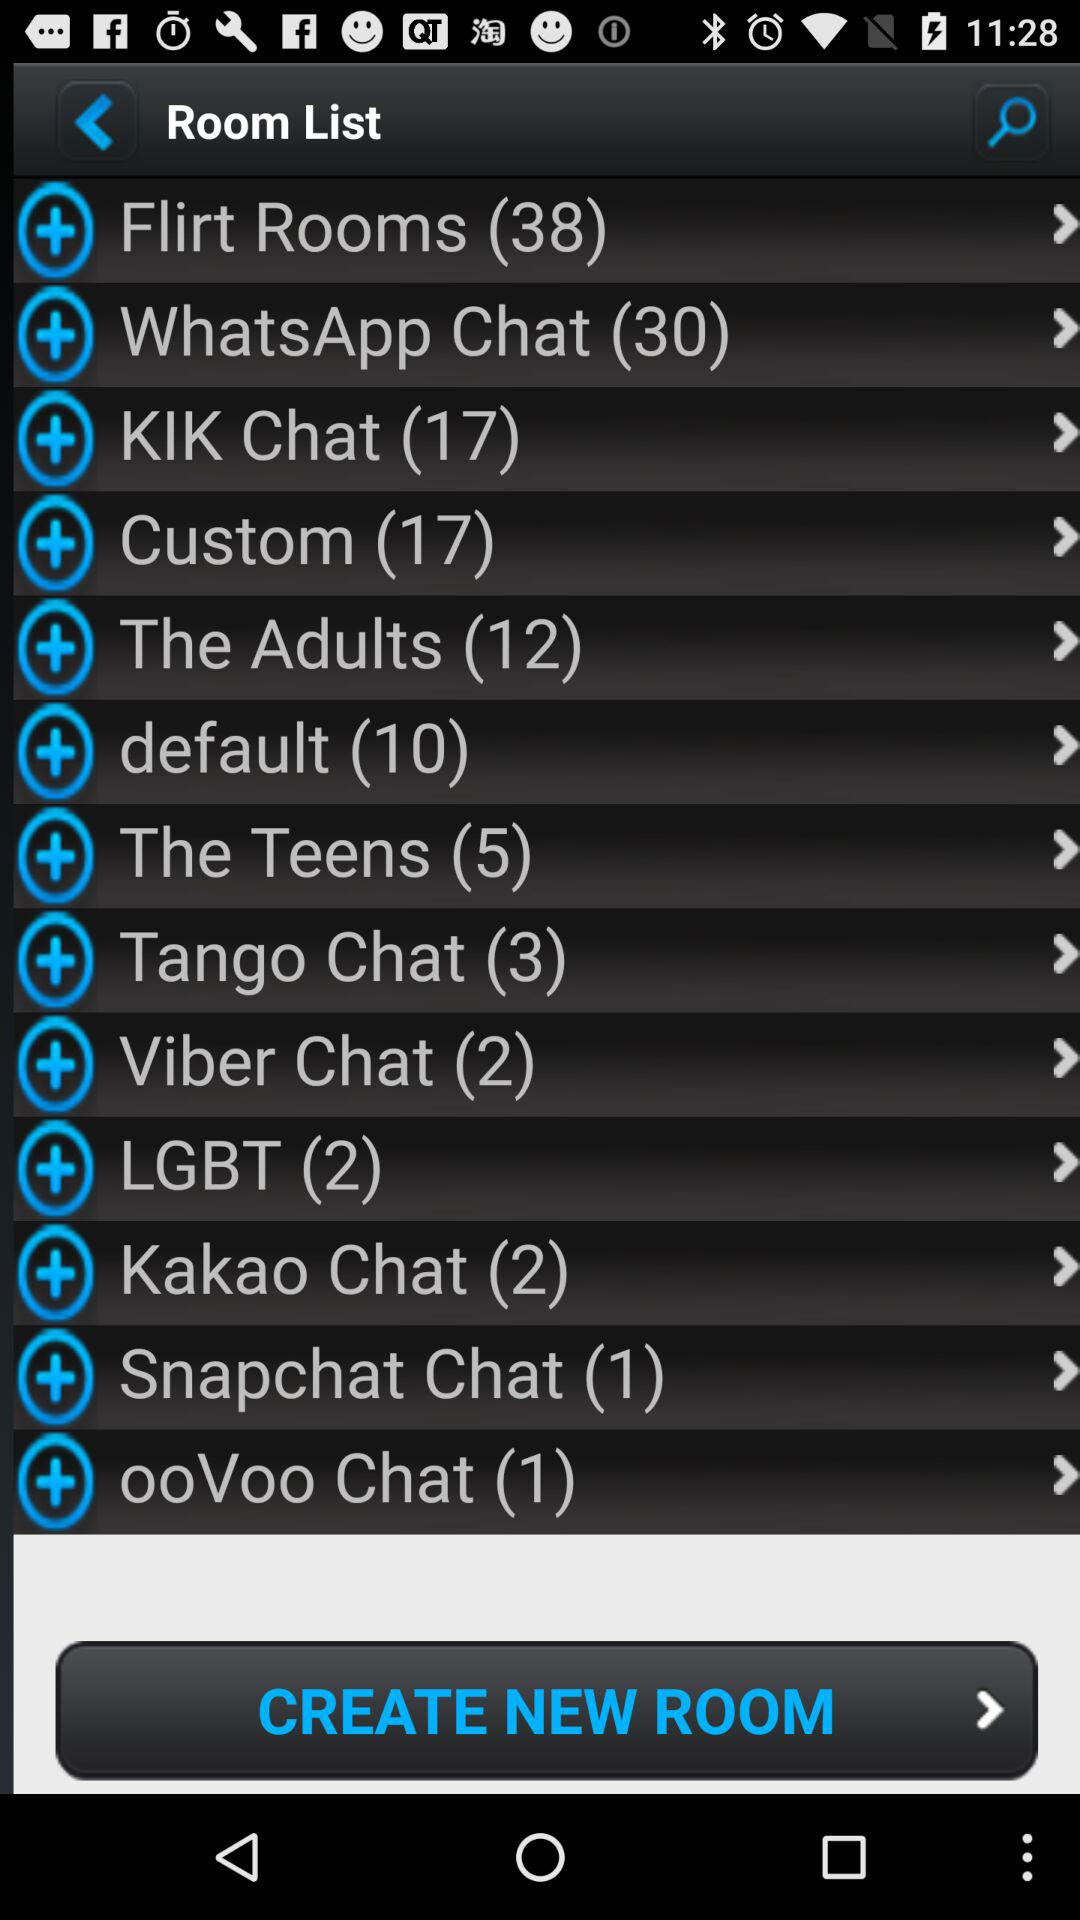What is the room list of Tango Chat? Tango Chat's room list is 3. 